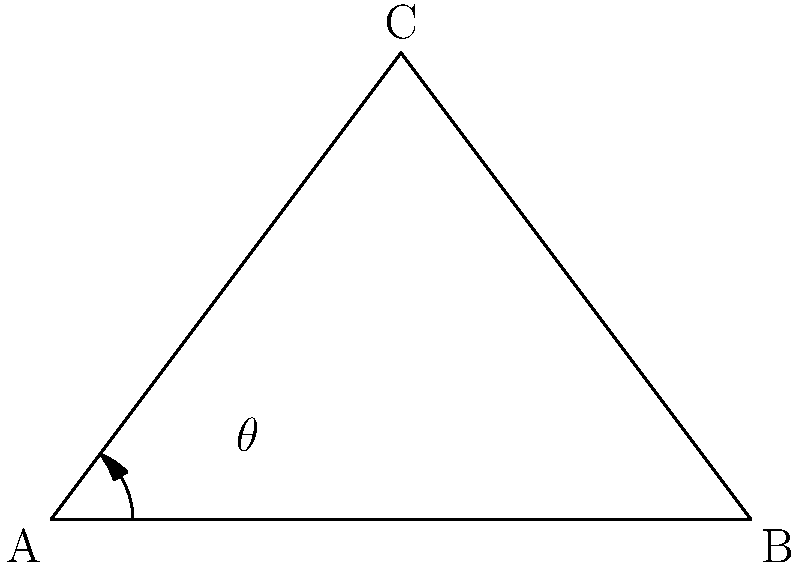As a self-sufficient farmer, you're designing a sloped greenhouse roof to maximize sunlight exposure. Given that the optimal angle for sunlight absorption in your area is 53°, and the base width of your greenhouse is 6 meters, what should be the height of the roof's peak to achieve this optimal angle? Let's approach this step-by-step:

1) The greenhouse roof forms a triangle. We know the base (width) is 6 meters, and we need to find the height.

2) The angle we're interested in is the one between the base and the sloped side, which is 53°.

3) In this triangle, we know:
   - The base (adjacent side to our angle) = 6 meters
   - The angle = 53°
   - We need to find the height (opposite side to our angle)

4) This is a perfect scenario to use the tangent trigonometric function. Recall that:

   $\tan(\theta) = \frac{\text{opposite}}{\text{adjacent}}$

5) In our case:

   $\tan(53°) = \frac{\text{height}}{3}$

   (Note: We use 3 meters, not 6, because the peak will be in the middle of the base)

6) To solve for height:

   $\text{height} = 3 \times \tan(53°)$

7) Using a calculator or trigonometric tables:

   $\text{height} = 3 \times 1.3270 \approx 3.981$ meters

Therefore, the height of the roof's peak should be approximately 3.981 meters to achieve the optimal 53° angle for sunlight exposure.
Answer: 3.981 meters 